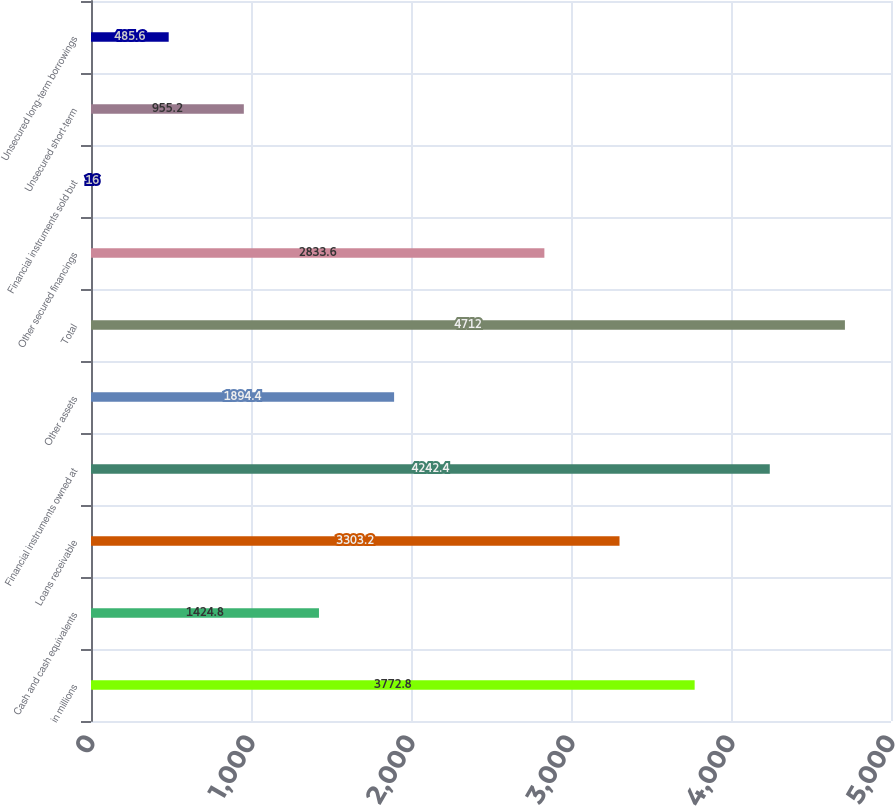Convert chart to OTSL. <chart><loc_0><loc_0><loc_500><loc_500><bar_chart><fcel>in millions<fcel>Cash and cash equivalents<fcel>Loans receivable<fcel>Financial instruments owned at<fcel>Other assets<fcel>Total<fcel>Other secured financings<fcel>Financial instruments sold but<fcel>Unsecured short-term<fcel>Unsecured long-term borrowings<nl><fcel>3772.8<fcel>1424.8<fcel>3303.2<fcel>4242.4<fcel>1894.4<fcel>4712<fcel>2833.6<fcel>16<fcel>955.2<fcel>485.6<nl></chart> 